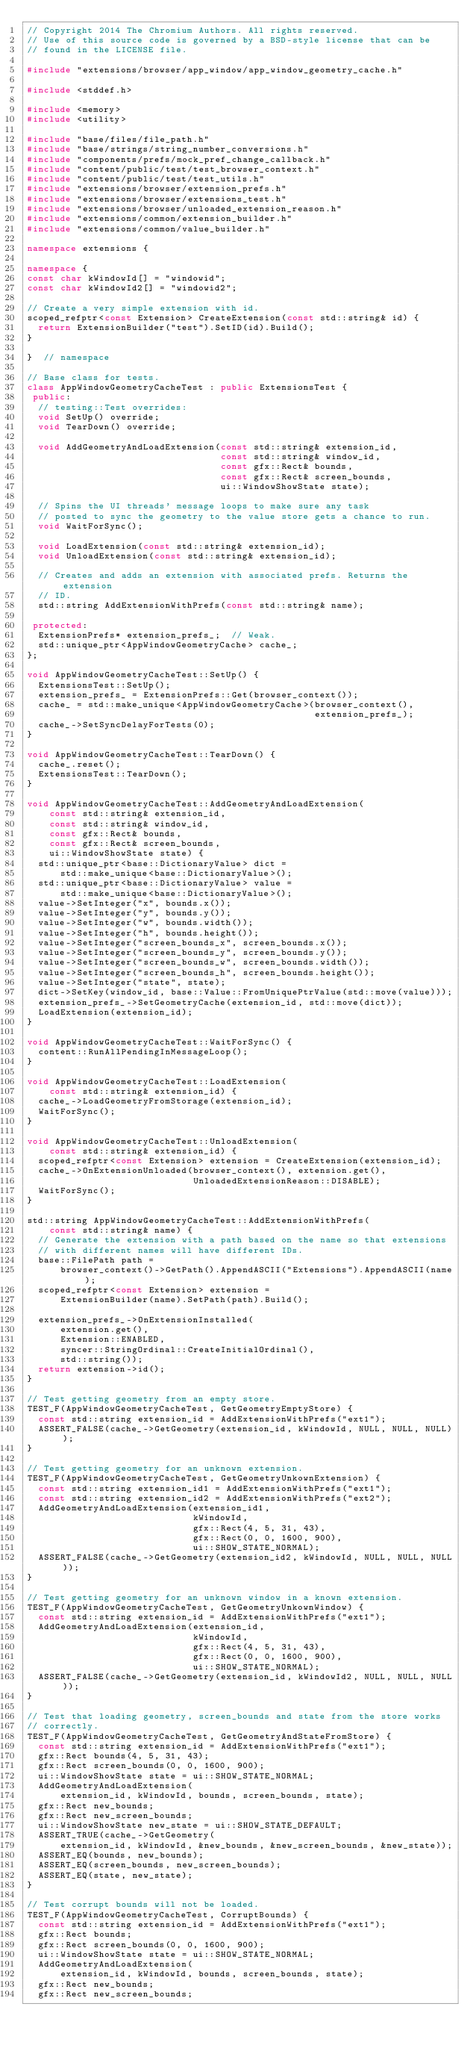<code> <loc_0><loc_0><loc_500><loc_500><_C++_>// Copyright 2014 The Chromium Authors. All rights reserved.
// Use of this source code is governed by a BSD-style license that can be
// found in the LICENSE file.

#include "extensions/browser/app_window/app_window_geometry_cache.h"

#include <stddef.h>

#include <memory>
#include <utility>

#include "base/files/file_path.h"
#include "base/strings/string_number_conversions.h"
#include "components/prefs/mock_pref_change_callback.h"
#include "content/public/test/test_browser_context.h"
#include "content/public/test/test_utils.h"
#include "extensions/browser/extension_prefs.h"
#include "extensions/browser/extensions_test.h"
#include "extensions/browser/unloaded_extension_reason.h"
#include "extensions/common/extension_builder.h"
#include "extensions/common/value_builder.h"

namespace extensions {

namespace {
const char kWindowId[] = "windowid";
const char kWindowId2[] = "windowid2";

// Create a very simple extension with id.
scoped_refptr<const Extension> CreateExtension(const std::string& id) {
  return ExtensionBuilder("test").SetID(id).Build();
}

}  // namespace

// Base class for tests.
class AppWindowGeometryCacheTest : public ExtensionsTest {
 public:
  // testing::Test overrides:
  void SetUp() override;
  void TearDown() override;

  void AddGeometryAndLoadExtension(const std::string& extension_id,
                                   const std::string& window_id,
                                   const gfx::Rect& bounds,
                                   const gfx::Rect& screen_bounds,
                                   ui::WindowShowState state);

  // Spins the UI threads' message loops to make sure any task
  // posted to sync the geometry to the value store gets a chance to run.
  void WaitForSync();

  void LoadExtension(const std::string& extension_id);
  void UnloadExtension(const std::string& extension_id);

  // Creates and adds an extension with associated prefs. Returns the extension
  // ID.
  std::string AddExtensionWithPrefs(const std::string& name);

 protected:
  ExtensionPrefs* extension_prefs_;  // Weak.
  std::unique_ptr<AppWindowGeometryCache> cache_;
};

void AppWindowGeometryCacheTest::SetUp() {
  ExtensionsTest::SetUp();
  extension_prefs_ = ExtensionPrefs::Get(browser_context());
  cache_ = std::make_unique<AppWindowGeometryCache>(browser_context(),
                                                    extension_prefs_);
  cache_->SetSyncDelayForTests(0);
}

void AppWindowGeometryCacheTest::TearDown() {
  cache_.reset();
  ExtensionsTest::TearDown();
}

void AppWindowGeometryCacheTest::AddGeometryAndLoadExtension(
    const std::string& extension_id,
    const std::string& window_id,
    const gfx::Rect& bounds,
    const gfx::Rect& screen_bounds,
    ui::WindowShowState state) {
  std::unique_ptr<base::DictionaryValue> dict =
      std::make_unique<base::DictionaryValue>();
  std::unique_ptr<base::DictionaryValue> value =
      std::make_unique<base::DictionaryValue>();
  value->SetInteger("x", bounds.x());
  value->SetInteger("y", bounds.y());
  value->SetInteger("w", bounds.width());
  value->SetInteger("h", bounds.height());
  value->SetInteger("screen_bounds_x", screen_bounds.x());
  value->SetInteger("screen_bounds_y", screen_bounds.y());
  value->SetInteger("screen_bounds_w", screen_bounds.width());
  value->SetInteger("screen_bounds_h", screen_bounds.height());
  value->SetInteger("state", state);
  dict->SetKey(window_id, base::Value::FromUniquePtrValue(std::move(value)));
  extension_prefs_->SetGeometryCache(extension_id, std::move(dict));
  LoadExtension(extension_id);
}

void AppWindowGeometryCacheTest::WaitForSync() {
  content::RunAllPendingInMessageLoop();
}

void AppWindowGeometryCacheTest::LoadExtension(
    const std::string& extension_id) {
  cache_->LoadGeometryFromStorage(extension_id);
  WaitForSync();
}

void AppWindowGeometryCacheTest::UnloadExtension(
    const std::string& extension_id) {
  scoped_refptr<const Extension> extension = CreateExtension(extension_id);
  cache_->OnExtensionUnloaded(browser_context(), extension.get(),
                              UnloadedExtensionReason::DISABLE);
  WaitForSync();
}

std::string AppWindowGeometryCacheTest::AddExtensionWithPrefs(
    const std::string& name) {
  // Generate the extension with a path based on the name so that extensions
  // with different names will have different IDs.
  base::FilePath path =
      browser_context()->GetPath().AppendASCII("Extensions").AppendASCII(name);
  scoped_refptr<const Extension> extension =
      ExtensionBuilder(name).SetPath(path).Build();

  extension_prefs_->OnExtensionInstalled(
      extension.get(),
      Extension::ENABLED,
      syncer::StringOrdinal::CreateInitialOrdinal(),
      std::string());
  return extension->id();
}

// Test getting geometry from an empty store.
TEST_F(AppWindowGeometryCacheTest, GetGeometryEmptyStore) {
  const std::string extension_id = AddExtensionWithPrefs("ext1");
  ASSERT_FALSE(cache_->GetGeometry(extension_id, kWindowId, NULL, NULL, NULL));
}

// Test getting geometry for an unknown extension.
TEST_F(AppWindowGeometryCacheTest, GetGeometryUnkownExtension) {
  const std::string extension_id1 = AddExtensionWithPrefs("ext1");
  const std::string extension_id2 = AddExtensionWithPrefs("ext2");
  AddGeometryAndLoadExtension(extension_id1,
                              kWindowId,
                              gfx::Rect(4, 5, 31, 43),
                              gfx::Rect(0, 0, 1600, 900),
                              ui::SHOW_STATE_NORMAL);
  ASSERT_FALSE(cache_->GetGeometry(extension_id2, kWindowId, NULL, NULL, NULL));
}

// Test getting geometry for an unknown window in a known extension.
TEST_F(AppWindowGeometryCacheTest, GetGeometryUnkownWindow) {
  const std::string extension_id = AddExtensionWithPrefs("ext1");
  AddGeometryAndLoadExtension(extension_id,
                              kWindowId,
                              gfx::Rect(4, 5, 31, 43),
                              gfx::Rect(0, 0, 1600, 900),
                              ui::SHOW_STATE_NORMAL);
  ASSERT_FALSE(cache_->GetGeometry(extension_id, kWindowId2, NULL, NULL, NULL));
}

// Test that loading geometry, screen_bounds and state from the store works
// correctly.
TEST_F(AppWindowGeometryCacheTest, GetGeometryAndStateFromStore) {
  const std::string extension_id = AddExtensionWithPrefs("ext1");
  gfx::Rect bounds(4, 5, 31, 43);
  gfx::Rect screen_bounds(0, 0, 1600, 900);
  ui::WindowShowState state = ui::SHOW_STATE_NORMAL;
  AddGeometryAndLoadExtension(
      extension_id, kWindowId, bounds, screen_bounds, state);
  gfx::Rect new_bounds;
  gfx::Rect new_screen_bounds;
  ui::WindowShowState new_state = ui::SHOW_STATE_DEFAULT;
  ASSERT_TRUE(cache_->GetGeometry(
      extension_id, kWindowId, &new_bounds, &new_screen_bounds, &new_state));
  ASSERT_EQ(bounds, new_bounds);
  ASSERT_EQ(screen_bounds, new_screen_bounds);
  ASSERT_EQ(state, new_state);
}

// Test corrupt bounds will not be loaded.
TEST_F(AppWindowGeometryCacheTest, CorruptBounds) {
  const std::string extension_id = AddExtensionWithPrefs("ext1");
  gfx::Rect bounds;
  gfx::Rect screen_bounds(0, 0, 1600, 900);
  ui::WindowShowState state = ui::SHOW_STATE_NORMAL;
  AddGeometryAndLoadExtension(
      extension_id, kWindowId, bounds, screen_bounds, state);
  gfx::Rect new_bounds;
  gfx::Rect new_screen_bounds;</code> 